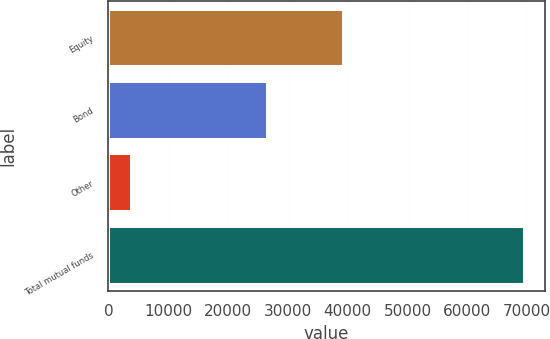Convert chart. <chart><loc_0><loc_0><loc_500><loc_500><bar_chart><fcel>Equity<fcel>Bond<fcel>Other<fcel>Total mutual funds<nl><fcel>39195<fcel>26519<fcel>3764<fcel>69478<nl></chart> 